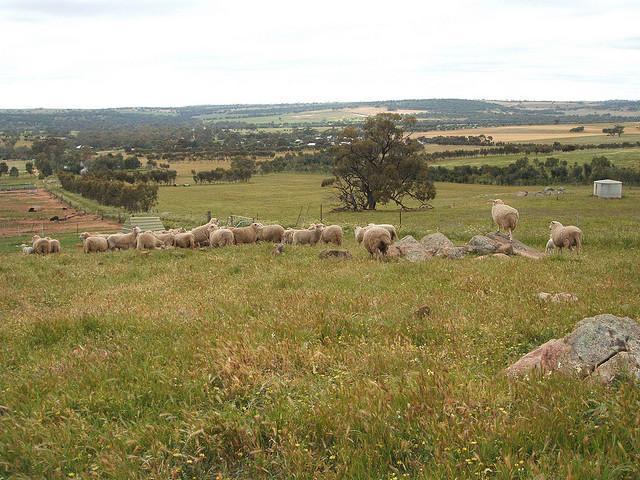How many people in the room?
Give a very brief answer. 0. 